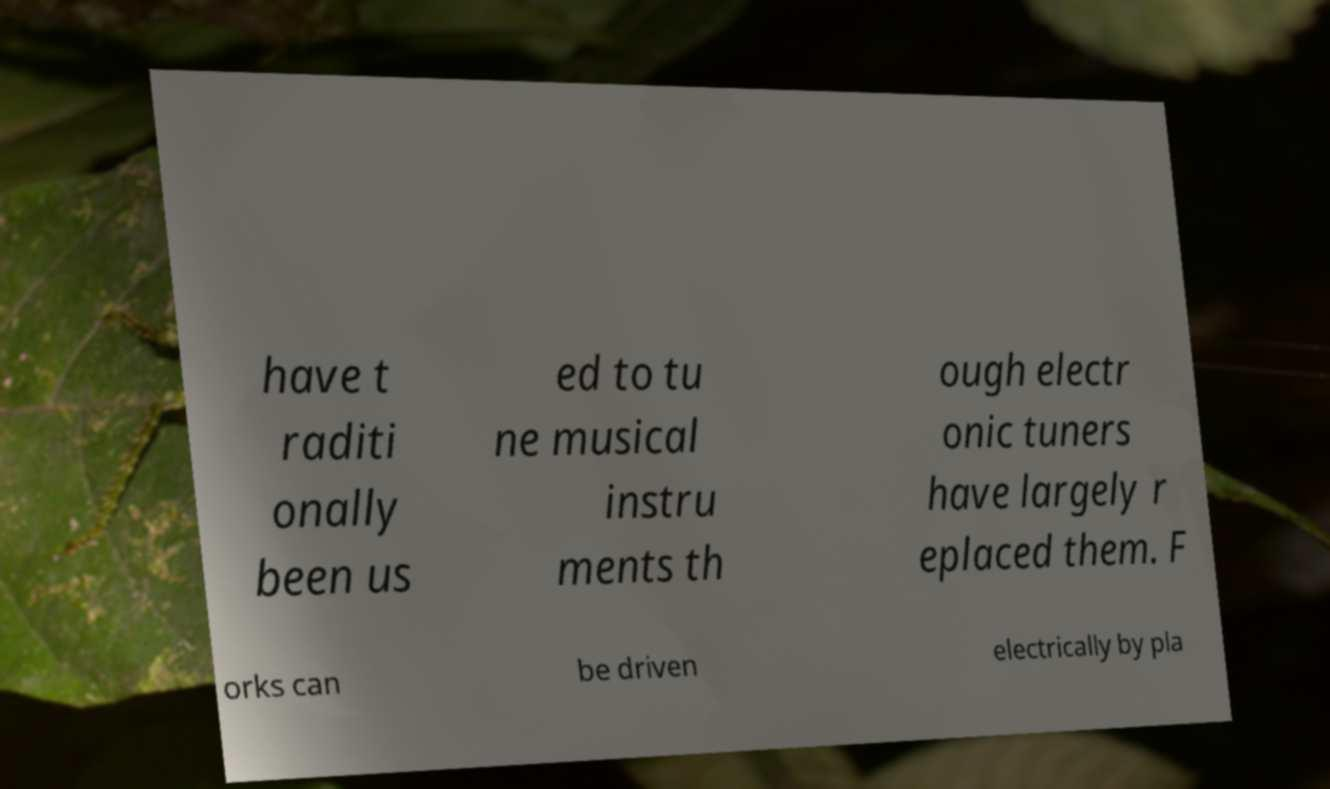Can you accurately transcribe the text from the provided image for me? have t raditi onally been us ed to tu ne musical instru ments th ough electr onic tuners have largely r eplaced them. F orks can be driven electrically by pla 